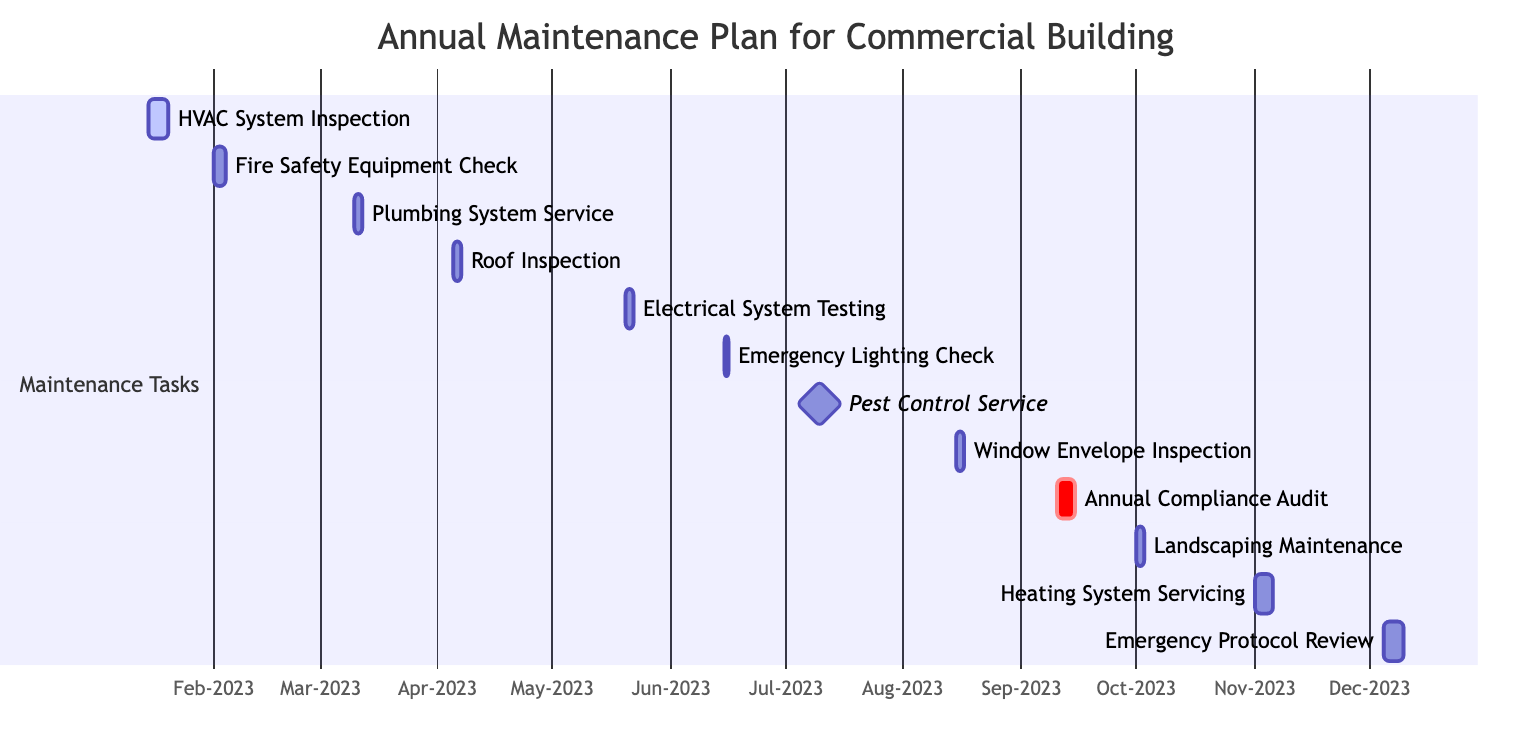What tasks are scheduled for June? Looking at the tasks for June on the Gantt Chart, I see that there are two tasks: "Emergency Lighting Check," which occurs on June 15 and is a one-day task, and "Pest Control Service," which is scheduled for July 10 but is a milestone. Therefore, only "Emergency Lighting Check" is scheduled for June.
Answer: Emergency Lighting Check How many days is the "Annual Compliance Audit"? The "Annual Compliance Audit" task spans from September 10 to September 15, which is calculated by counting the days: September 10, 11, 12, 13, 14, and 15, totaling 5 days.
Answer: 5 days Which task has the shortest duration? Upon examining the tasks, "Emergency Lighting Check" and "Pest Control Service" each last for 1 day, making them the shortest tasks in terms of duration.
Answer: 1 day What is the sequence of tasks for March? In March, starting with the "Plumbing System Service" from March 10 to March 12, there are no other tasks in this month, establishing the sequence as just this task alone.
Answer: Plumbing System Service Which task is scheduled to start directly after the "Emergency Lighting Check"? The "Emergency Lighting Check" ends on June 16 and the next task, "Pest Control Service," begins on July 10. Therefore, these two tasks are sequential but have a gap, making "Pest Control Service" the next scheduled task.
Answer: Pest Control Service What is the total number of maintenance tasks scheduled? By counting each task listed in the Gantt Chart, there are a total of 12 tasks planned throughout the year.
Answer: 12 tasks How many inspections are scheduled between January and April? In this timeframe, there are three inspections: "HVAC System Inspection" in January, "Roof Inspection" in April, and while "Fire Safety Equipment Check" occurs in February, it is not categorized as an inspection but rather as a safety equipment check. Thus, only two are inspections.
Answer: 2 inspections When is the "Heating System Servicing" scheduled? This task is scheduled to occur from November 1 through November 5, making these dates important for preparation and notification.
Answer: November 1 to November 5 What task occurs in August? In August, the task present is the "Window Envelope Inspection," scheduled from August 15 to August 17.
Answer: Window Envelope Inspection 